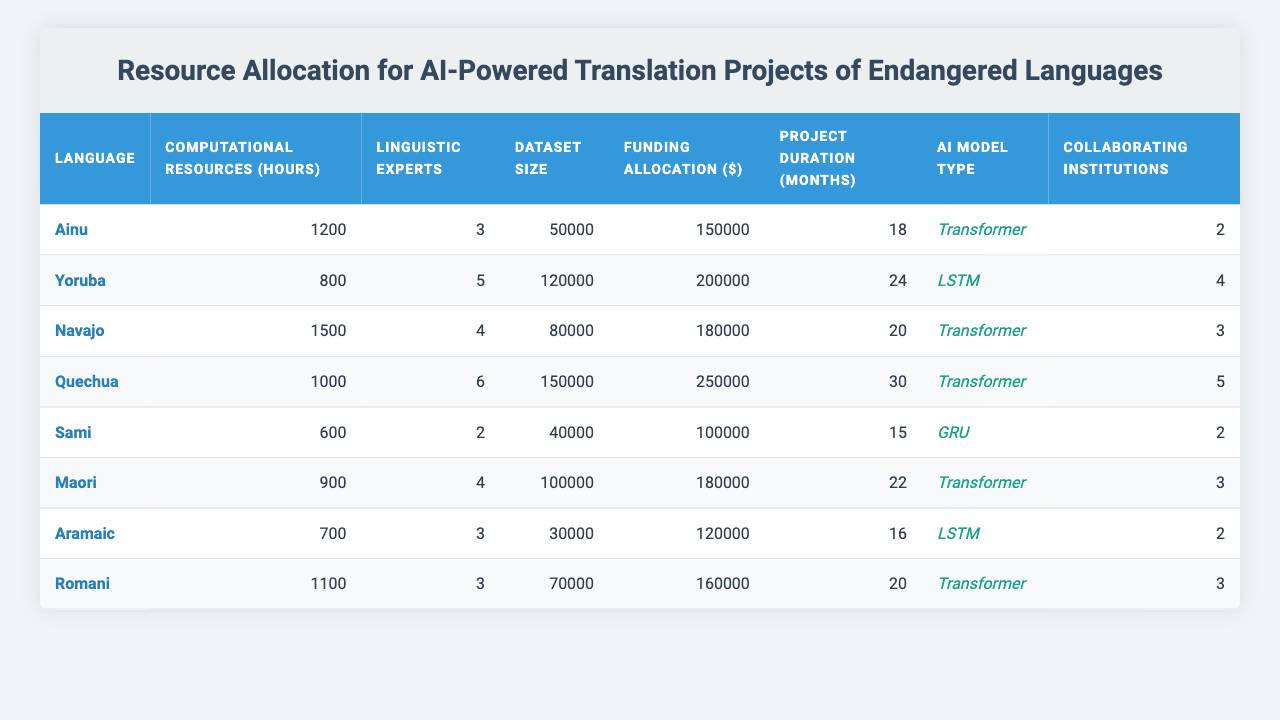What is the language with the highest funding allocation? The funding allocations in the table are: 150000, 200000, 180000, 250000, 100000, 180000, 120000, 160000. The highest value is 250000 for Quechua.
Answer: Quechua How many computational resources are allocated for the Navajo language? The table shows that Navajo has 1500 computational resources allocated.
Answer: 1500 Which language has the least number of linguistic experts? The values for linguistic experts are: 3, 5, 4, 6, 2, 4, 3, 3. The minimum is 2 for Sami.
Answer: Sami What is the average dataset size for the languages listed? The dataset sizes are: 50000, 120000, 80000, 150000, 40000, 100000, 30000, 70000. Summing these gives 50000 + 120000 + 80000 + 150000 + 40000 + 100000 + 30000 + 70000 = 600000. There are 8 languages, so the average is 600000 / 8 = 75000.
Answer: 75000 Is the project duration for Maori more than 20 months? The project duration for Maori is 22 months, which is greater than 20 months.
Answer: Yes Which AI model type is used for the language with the smallest dataset size? The smallest dataset size is 30000, corresponding to Romani, which uses the Transformer model.
Answer: Transformer What is the total funding allocation for all the languages? The funding allocation values are: 150000, 200000, 180000, 250000, 100000, 180000, 120000, 160000. Summing these gives 150000 + 200000 + 180000 + 250000 + 100000 + 180000 + 120000 + 160000 = 1240000.
Answer: 1240000 Which language has the highest number of collaborating institutions? The values for collaborating institutions are: 2, 4, 3, 5, 2, 3, 2, 3. The highest value is 5 for Quechua.
Answer: Quechua In terms of computational resources, how much more is allocated to the languages that use Transformer models compared to those that do not? The languages using Transformers are Ainu, Navajo, Quechua, Maori, and Romani which have resource allocations of 1200, 1500, 1000, 900, and 1100 respectively, totaling 1200 + 1500 + 1000 + 900 + 1100 = 5800. The non-Transformer models (Yoruba, Sami, and Aramaic) have 800, 600, and 700, totaling 800 + 600 + 700 = 2100. The difference is 5800 - 2100 = 3700.
Answer: 3700 What percentage of the total funding is allocated to the Sami language? The Sami language has a funding allocation of 100000. The total funding is 1240000, so the percentage is (100000 / 1240000) * 100 ≈ 8.06%.
Answer: Approximately 8.06% 